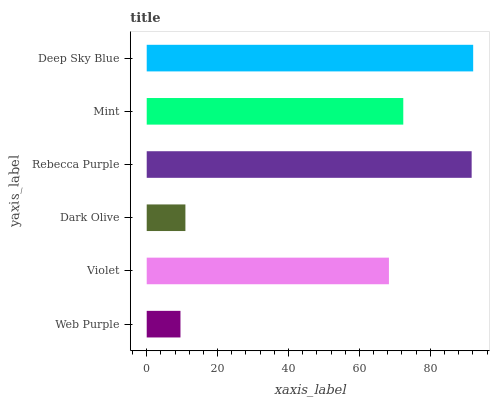Is Web Purple the minimum?
Answer yes or no. Yes. Is Deep Sky Blue the maximum?
Answer yes or no. Yes. Is Violet the minimum?
Answer yes or no. No. Is Violet the maximum?
Answer yes or no. No. Is Violet greater than Web Purple?
Answer yes or no. Yes. Is Web Purple less than Violet?
Answer yes or no. Yes. Is Web Purple greater than Violet?
Answer yes or no. No. Is Violet less than Web Purple?
Answer yes or no. No. Is Mint the high median?
Answer yes or no. Yes. Is Violet the low median?
Answer yes or no. Yes. Is Web Purple the high median?
Answer yes or no. No. Is Rebecca Purple the low median?
Answer yes or no. No. 